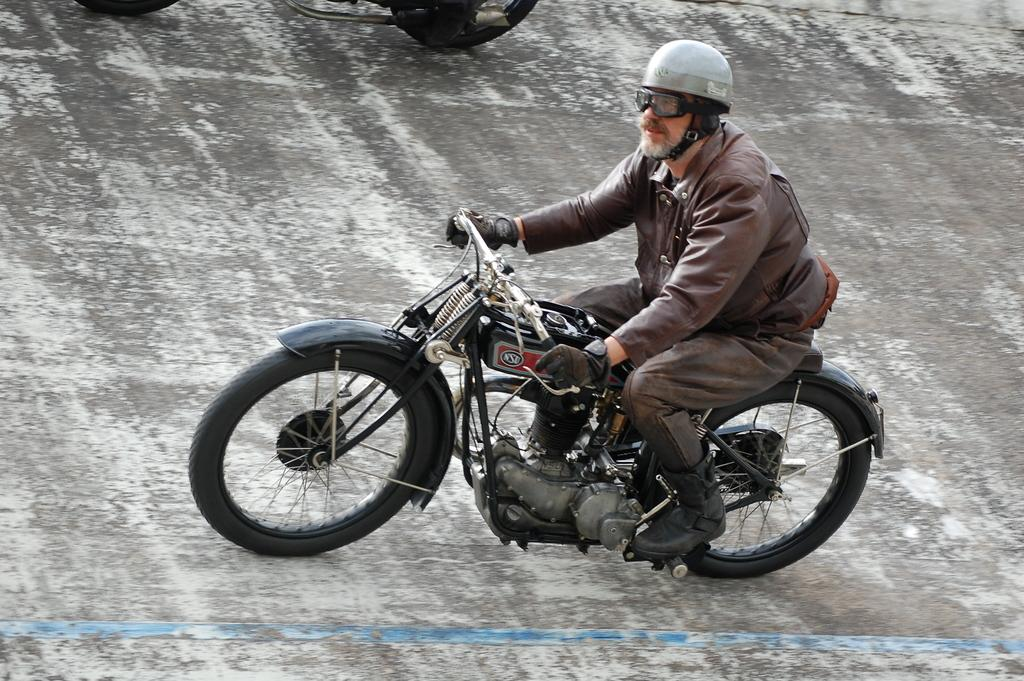Where was the image taken? The image is taken on the road. What is the main subject in the image? There is a man in the center of the image. What is the man wearing? The man is wearing a jacket. What mode of transportation is the man using? The man is riding a motorbike. Where is the faucet located in the image? There is no faucet present in the image. How many houses can be seen in the background of the image? There are no houses visible in the image; it is taken on the road with no buildings in the background. 